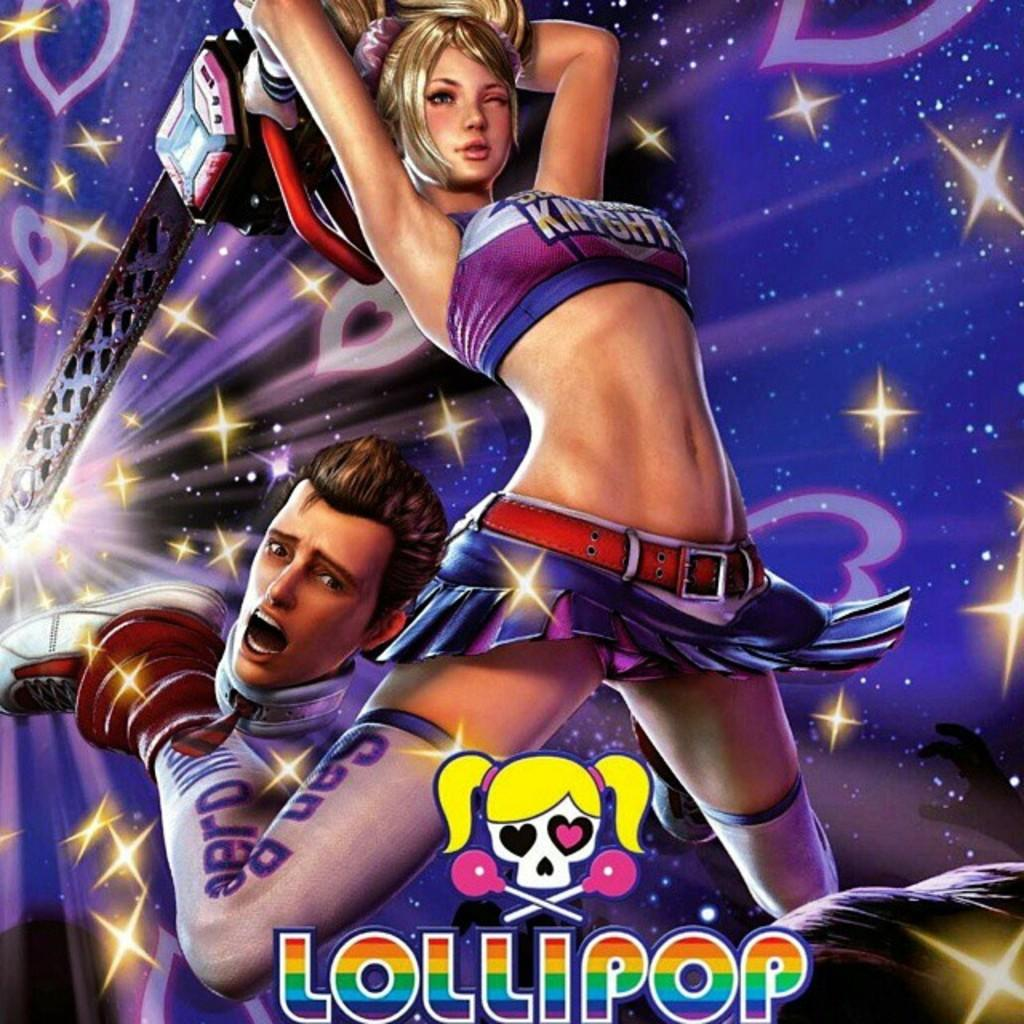<image>
Share a concise interpretation of the image provided. Lollipop comic drawing with a man and girl on the front 